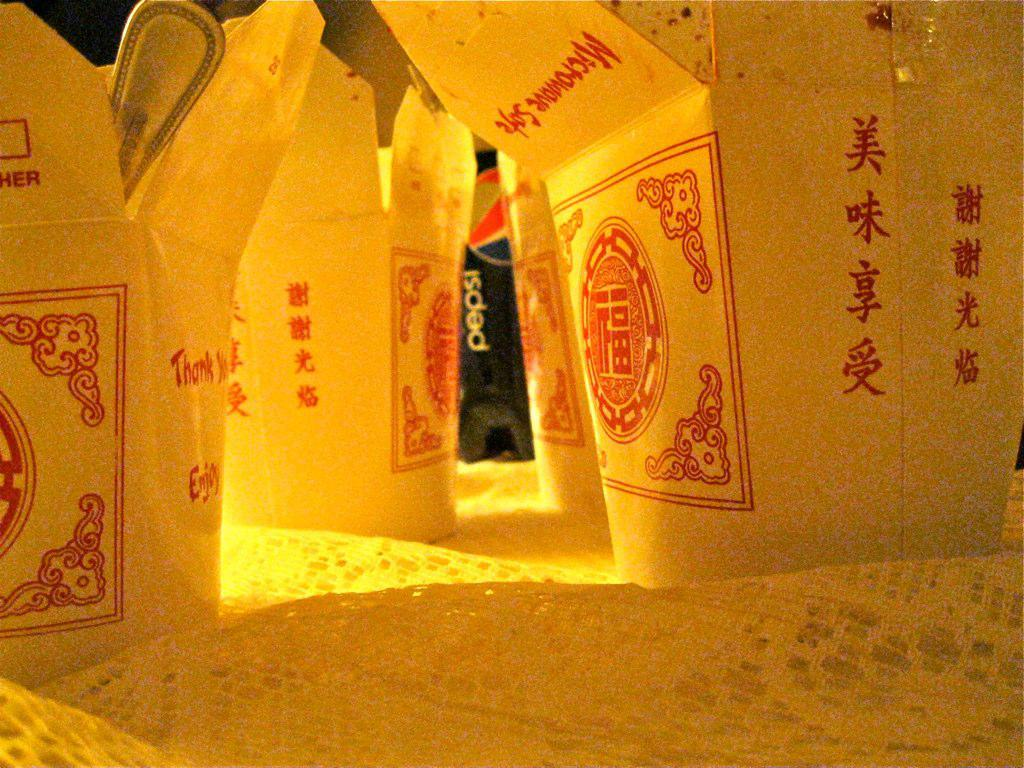<image>
Summarize the visual content of the image. Various food boxes that are labeled microwave safe 